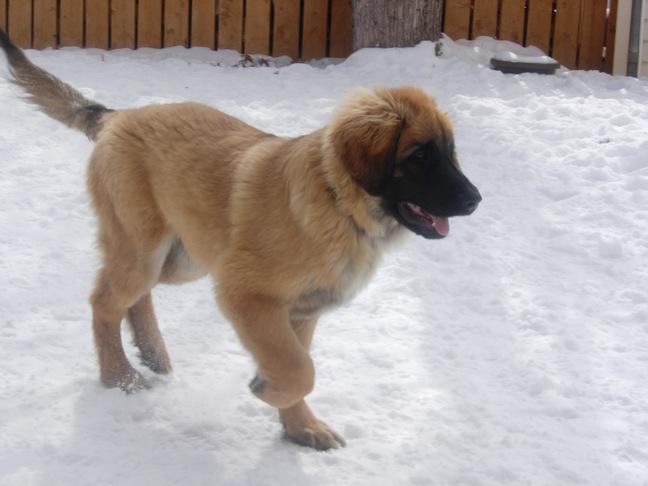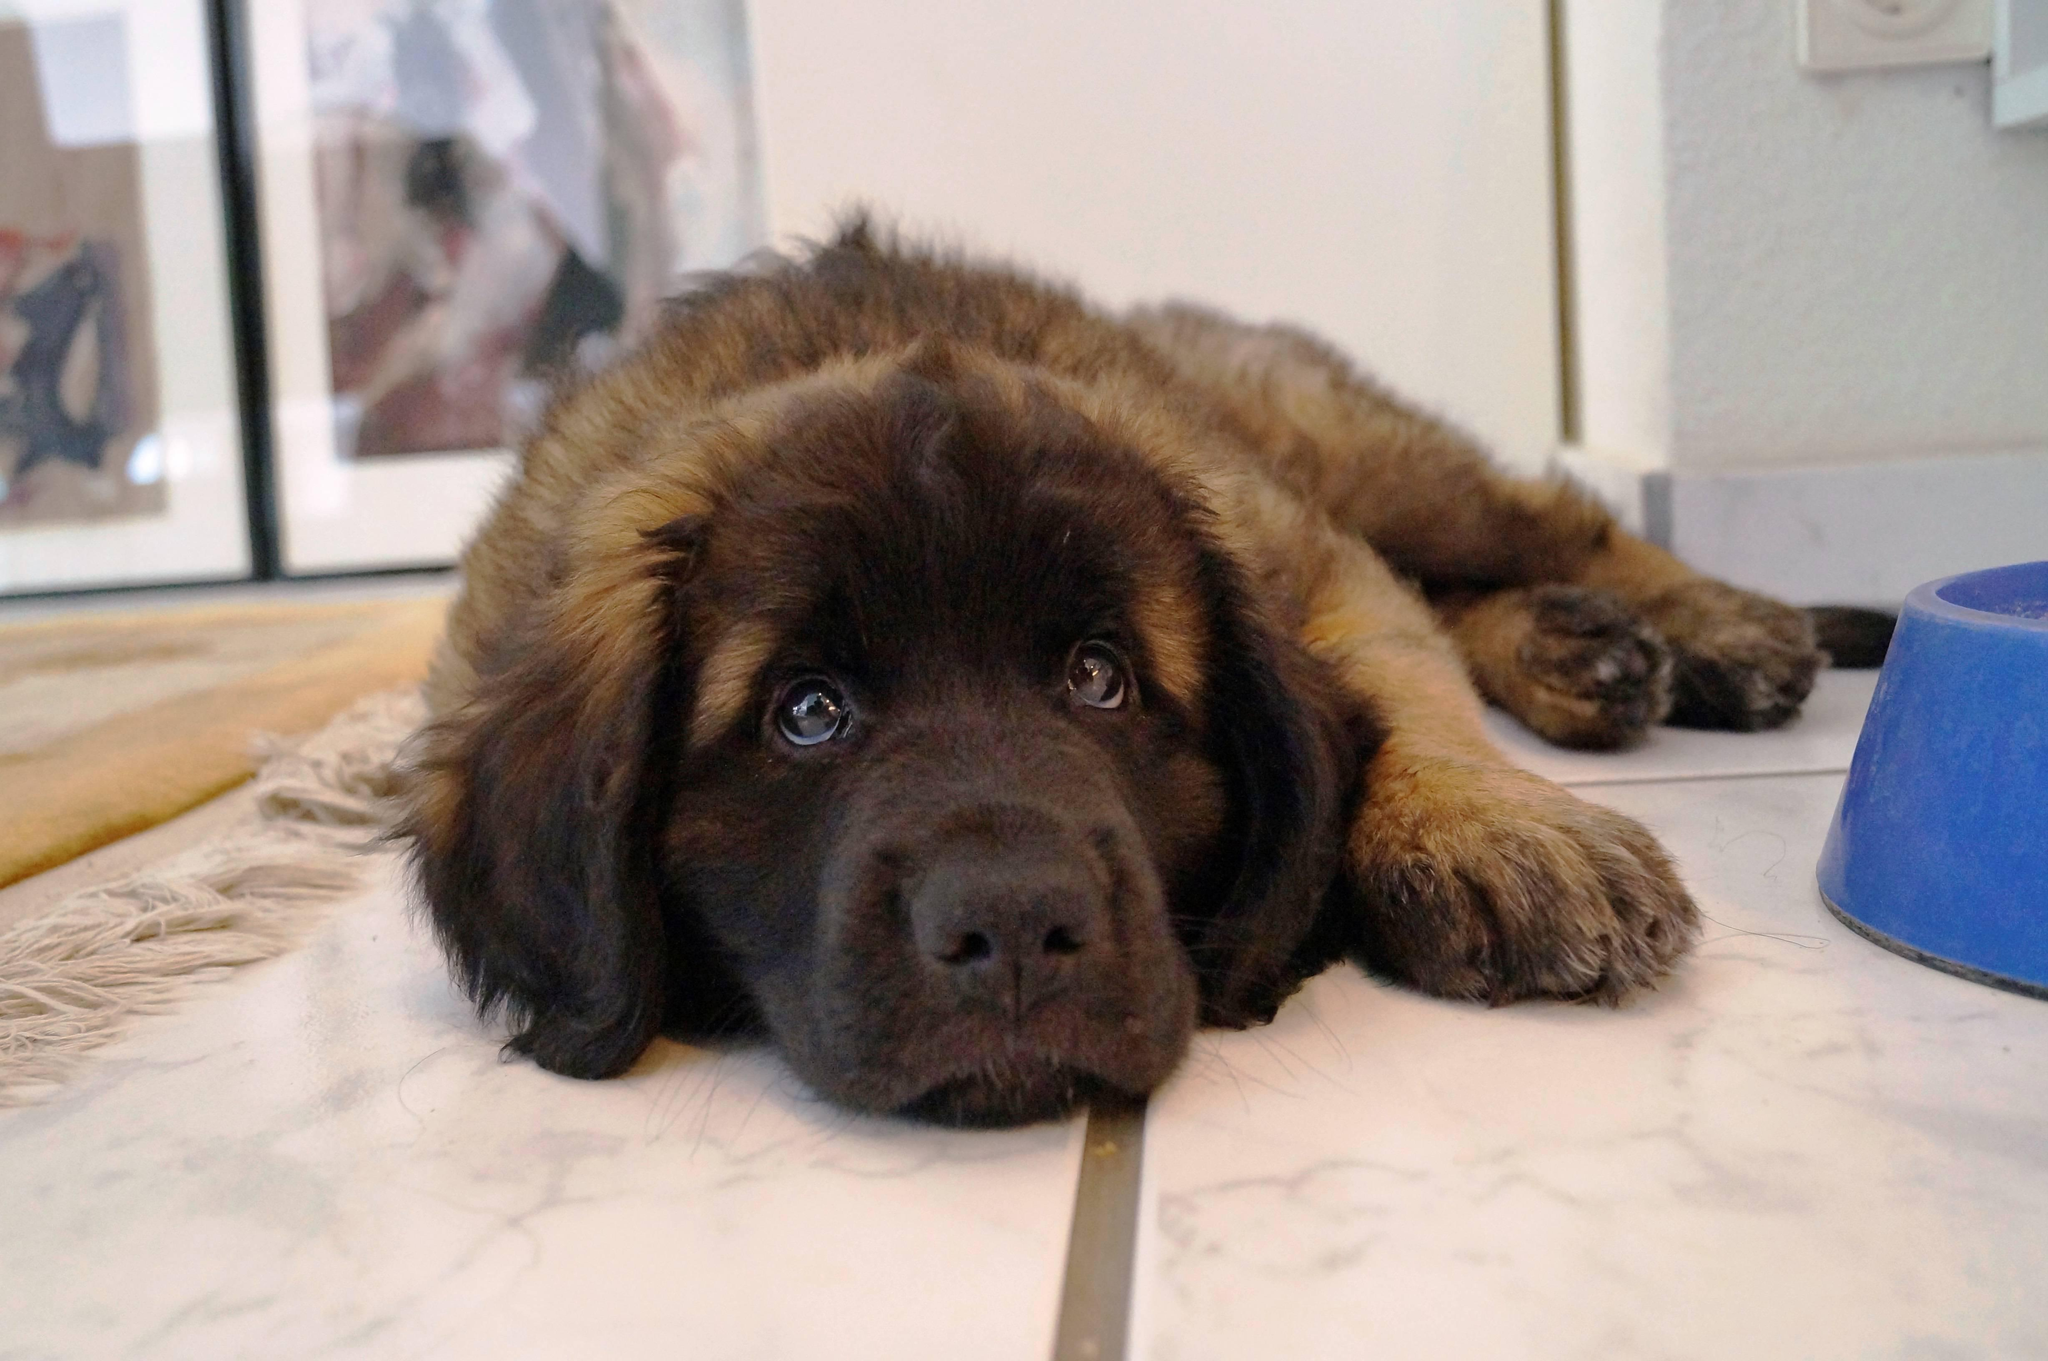The first image is the image on the left, the second image is the image on the right. Given the left and right images, does the statement "There are two dogs, and one visible tongue." hold true? Answer yes or no. Yes. The first image is the image on the left, the second image is the image on the right. For the images shown, is this caption "A larger animal is partly visible to the right of a puppy in an indoor setting." true? Answer yes or no. No. 